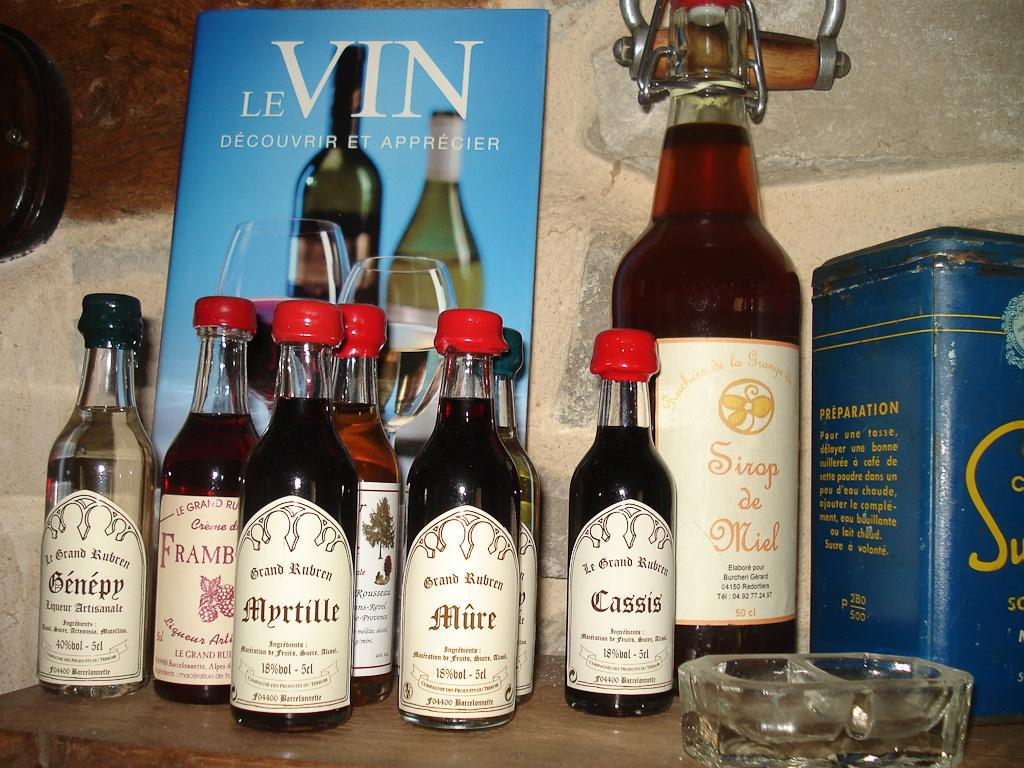Provide a one-sentence caption for the provided image. A bunch of bottles in front of a card that reads "Le Vin". 